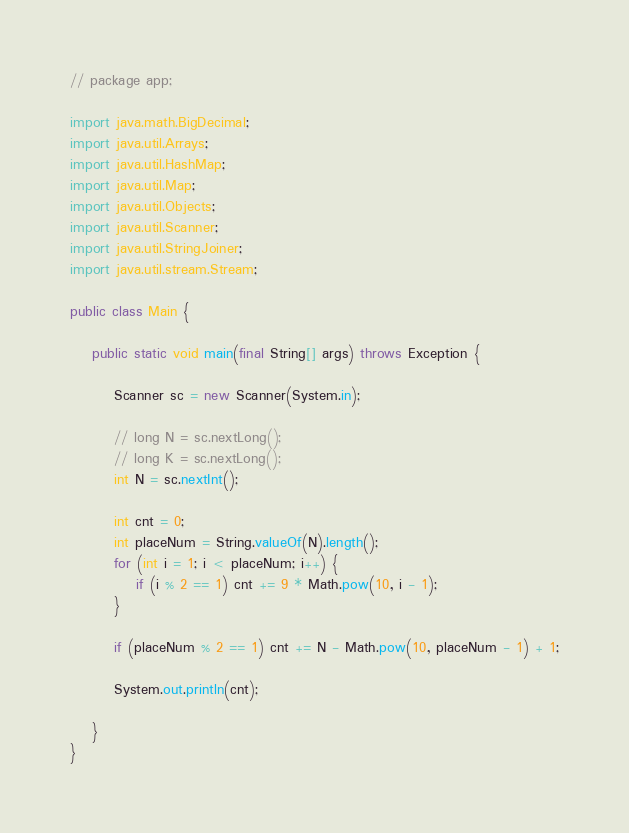Convert code to text. <code><loc_0><loc_0><loc_500><loc_500><_Java_>// package app;

import java.math.BigDecimal;
import java.util.Arrays;
import java.util.HashMap;
import java.util.Map;
import java.util.Objects;
import java.util.Scanner;
import java.util.StringJoiner;
import java.util.stream.Stream;

public class Main {

    public static void main(final String[] args) throws Exception {

        Scanner sc = new Scanner(System.in);

        // long N = sc.nextLong();
        // long K = sc.nextLong();
        int N = sc.nextInt();

        int cnt = 0;
        int placeNum = String.valueOf(N).length();
        for (int i = 1; i < placeNum; i++) {
            if (i % 2 == 1) cnt += 9 * Math.pow(10, i - 1);
        }

        if (placeNum % 2 == 1) cnt += N - Math.pow(10, placeNum - 1) + 1;

        System.out.println(cnt);

    }
}</code> 